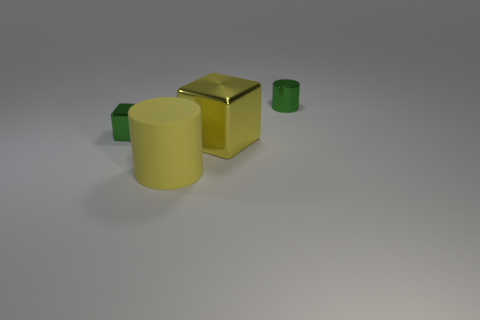Are there the same number of small green metallic cubes in front of the green block and tiny cylinders behind the yellow metallic cube?
Offer a very short reply. No. What size is the green thing that is the same material as the green cylinder?
Offer a terse response. Small. The tiny shiny cylinder is what color?
Keep it short and to the point. Green. What number of large cylinders have the same color as the big rubber object?
Give a very brief answer. 0. There is a yellow cube that is the same size as the matte cylinder; what is it made of?
Offer a terse response. Metal. There is a small green metallic thing that is left of the tiny green cylinder; is there a yellow shiny cube left of it?
Offer a terse response. No. How many other things are the same color as the large shiny thing?
Your response must be concise. 1. What is the size of the yellow rubber thing?
Your answer should be very brief. Large. Are there any big purple metallic blocks?
Give a very brief answer. No. Is the number of green cylinders that are to the right of the large matte cylinder greater than the number of green metal cylinders left of the tiny green cube?
Offer a very short reply. Yes. 